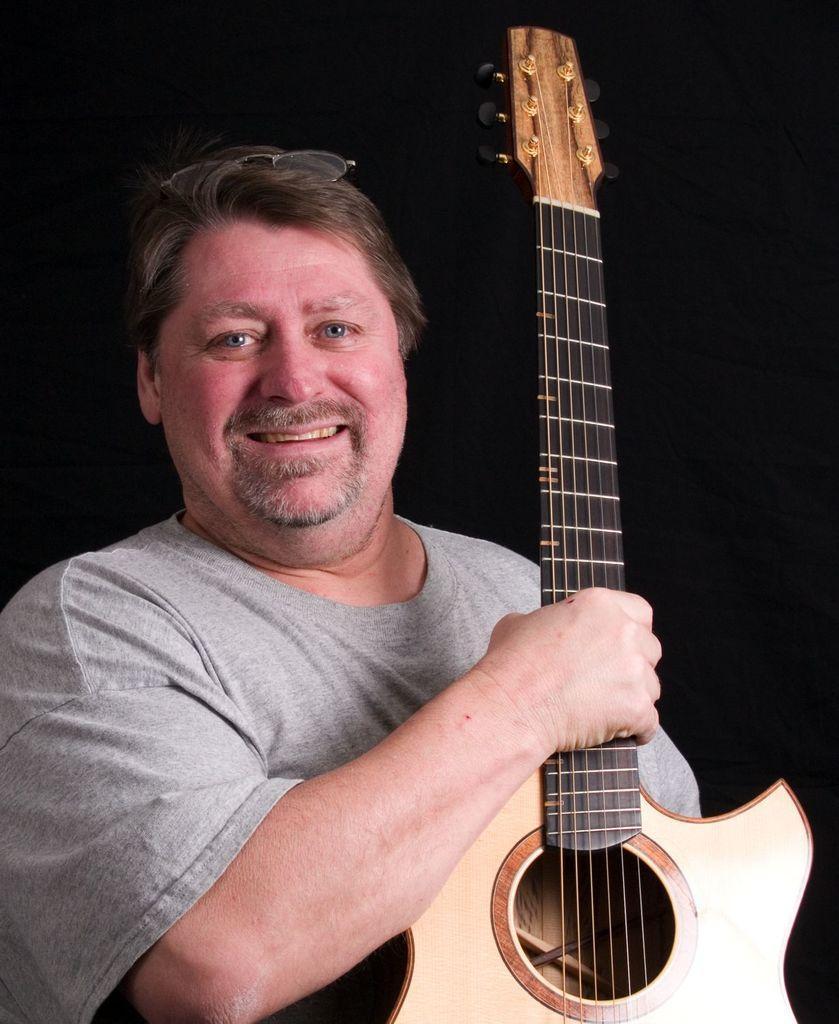Describe this image in one or two sentences. Here we can see a man with a guitar in his hand smiling 